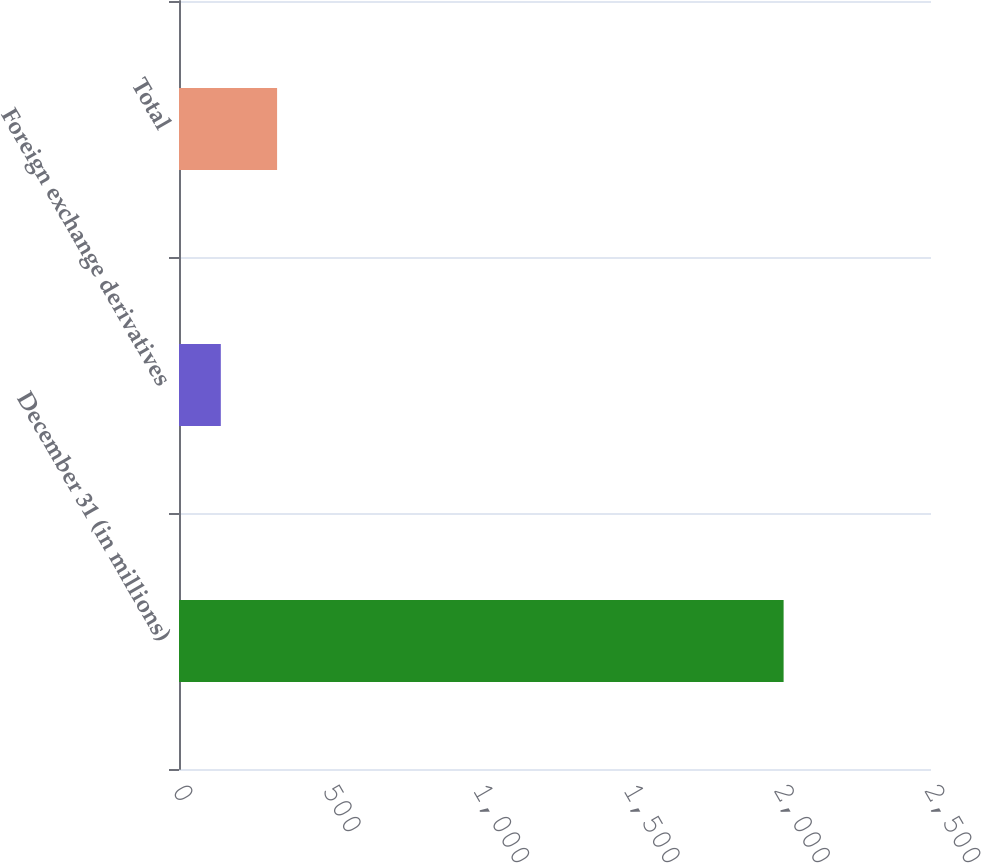Convert chart to OTSL. <chart><loc_0><loc_0><loc_500><loc_500><bar_chart><fcel>December 31 (in millions)<fcel>Foreign exchange derivatives<fcel>Total<nl><fcel>2010<fcel>139<fcel>326.1<nl></chart> 